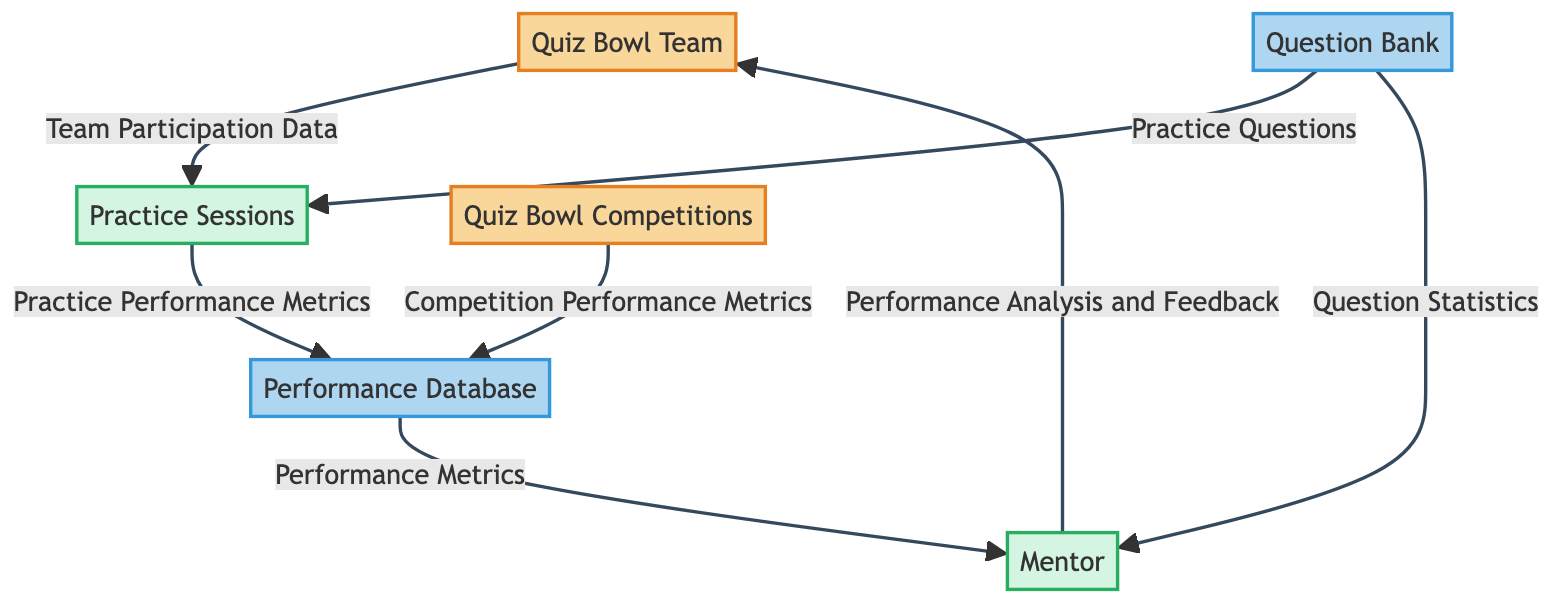What is the external entity that collects data from competitions? The external entity is "Quiz Bowl Competitions," which gathers and evaluates team performance in real-time, providing data for analysis.
Answer: Quiz Bowl Competitions How many processes are present in the diagram? The diagram includes three processes: "Mentor," "Practice Sessions," and "Quiz Bowl Competitions," leading to a total count of three.
Answer: 3 What type of data flows from the Practice Sessions to the Performance Database? The type of data flowing from "Practice Sessions" to "Performance Database" is "Practice Performance Metrics," which indicates the performance data that is stored.
Answer: Practice Performance Metrics Which entity provides feedback to the Quiz Bowl Team? The entity providing feedback to the Quiz Bowl Team is the "Mentor," who offers analysis and performance feedback based on various metrics.
Answer: Mentor What is the source of the questions used during practice sessions? The source of the questions used in the "Practice Sessions" is the "Question Bank," which supplies practice questions for the team to use.
Answer: Question Bank What kind of data does the Mentor access from the Performance Database? The Mentor accesses "Performance Metrics" from the Performance Database, which includes data on both individual and team performance metrics.
Answer: Performance Metrics Explain the flow of data from the Practice Sessions to the Mentor. The flow begins with the team participating in "Practice Sessions," where performance metrics are collected and stored in the "Performance Database." The "Mentor," then accesses this data to provide analysis and feedback to improve team performance.
Answer: Practice Performance Metrics to Performance Metrics How many data stores are present in the diagram? The diagram contains two data stores: "Question Bank" and "Performance Database," accounting for the total number of data stores.
Answer: 2 What kind of metrics are recorded from Quiz Bowl Competitions? The metrics recorded from Quiz Bowl Competitions are "Competition Performance Metrics," which capture the performance of the team during actual events.
Answer: Competition Performance Metrics 